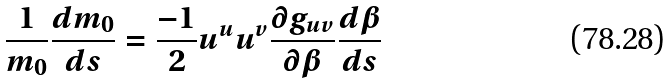<formula> <loc_0><loc_0><loc_500><loc_500>\frac { 1 } { m _ { 0 } } \frac { d m _ { 0 } } { d s } = \frac { - 1 } { 2 } u ^ { u } u ^ { v } \frac { \partial g _ { u v } } { \partial \beta } \frac { d \beta } { d s }</formula> 